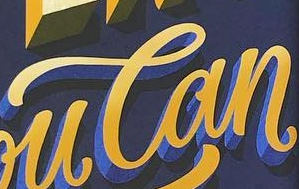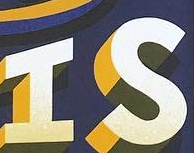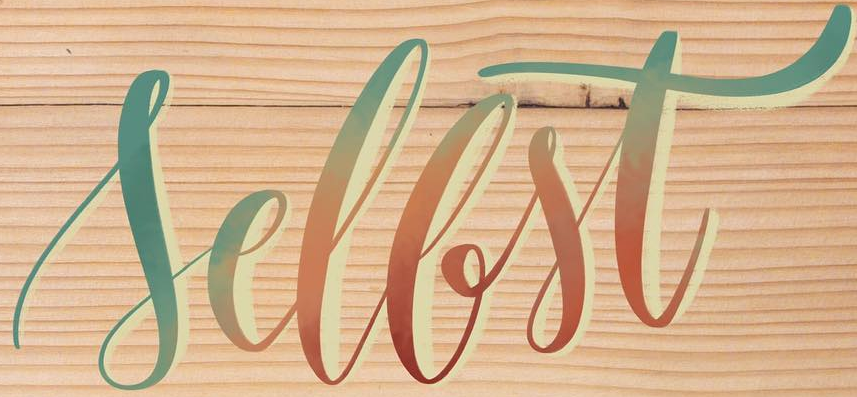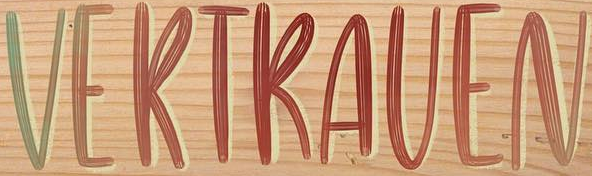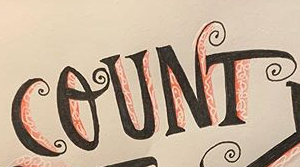What text appears in these images from left to right, separated by a semicolon? Can; IS; Sellst; VERTRAVEN; COUNT 